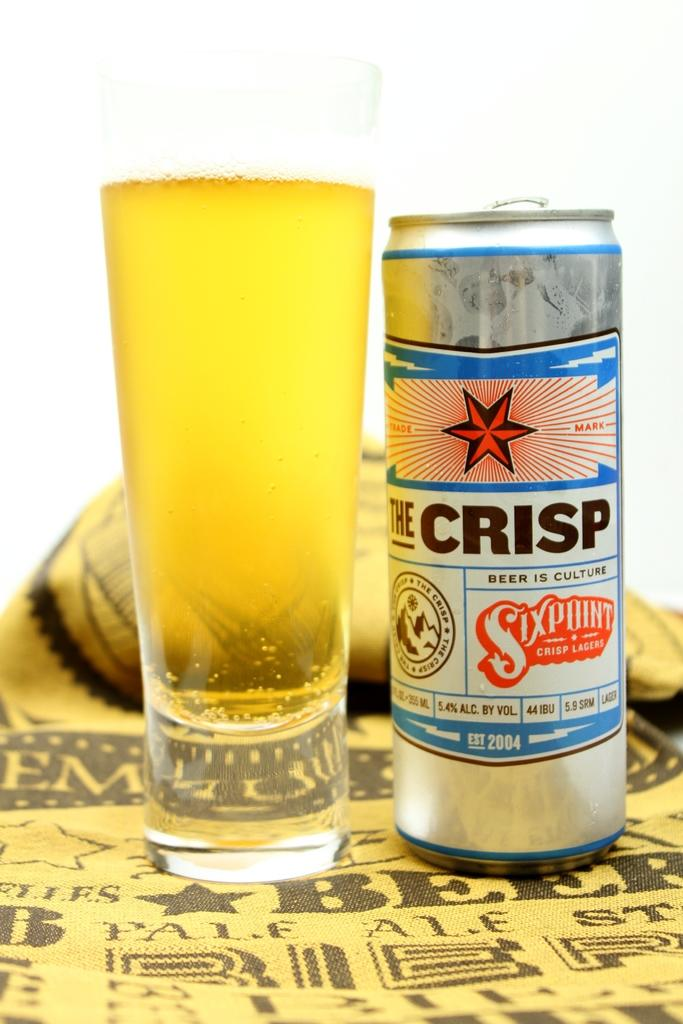<image>
Share a concise interpretation of the image provided. A can of The Crisp has a red star on the label. 